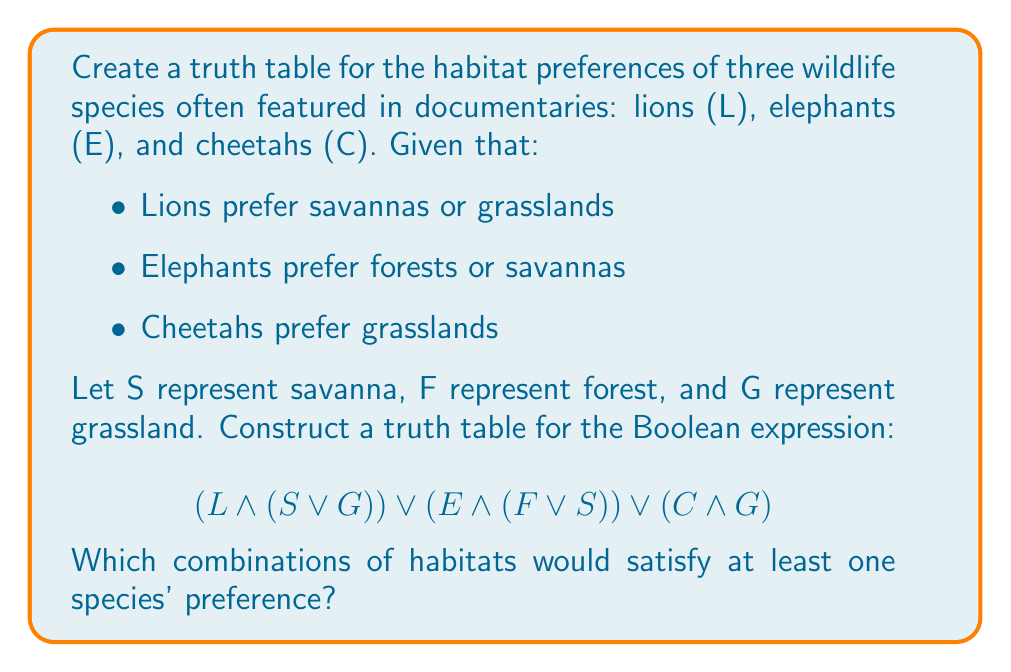Give your solution to this math problem. Let's approach this step-by-step:

1) First, we need to identify our variables:
   S (Savanna), F (Forest), G (Grassland)

2) We'll create a truth table with 8 rows (2^3 possibilities):

   | S | F | G | L∧(S∨G) | E∧(F∨S) | C∧G | Result |
   |---|---|---|---------|---------|-----|--------|
   | 0 | 0 | 0 |    0    |    0    |  0  |   0    |
   | 0 | 0 | 1 |    1    |    0    |  1  |   1    |
   | 0 | 1 | 0 |    0    |    1    |  0  |   1    |
   | 0 | 1 | 1 |    1    |    1    |  1  |   1    |
   | 1 | 0 | 0 |    1    |    1    |  0  |   1    |
   | 1 | 0 | 1 |    1    |    1    |  1  |   1    |
   | 1 | 1 | 0 |    1    |    1    |  0  |   1    |
   | 1 | 1 | 1 |    1    |    1    |  1  |   1    |

3) Explanation of each column:
   - L∧(S∨G): True when S or G is true (Lions prefer savannas or grasslands)
   - E∧(F∨S): True when F or S is true (Elephants prefer forests or savannas)
   - C∧G: True when G is true (Cheetahs prefer grasslands)

4) The Result column is the OR (∨) of the three previous columns, representing the entire expression.

5) From the truth table, we can see that the expression is false only when S=0, F=0, and G=0 (no suitable habitat for any species).

6) Therefore, any combination of habitats except for the case where none are present (S=F=G=0) would satisfy at least one species' preference.
Answer: 7 out of 8 habitat combinations satisfy at least one species' preference: (0,0,1), (0,1,0), (0,1,1), (1,0,0), (1,0,1), (1,1,0), (1,1,1) 